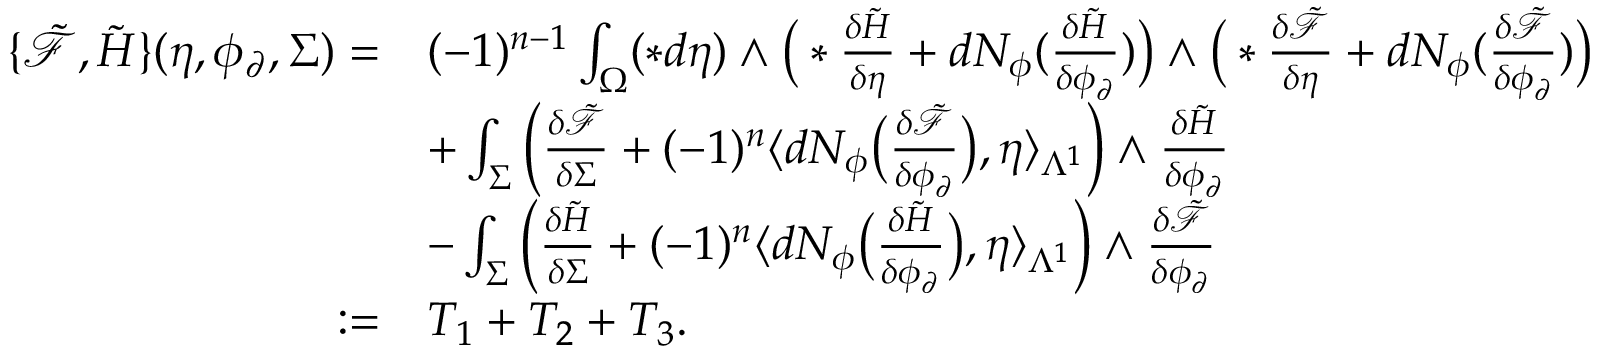Convert formula to latex. <formula><loc_0><loc_0><loc_500><loc_500>\begin{array} { r l } { \{ \tilde { \mathcal { F } } , \tilde { H } \} ( \eta , \phi _ { \partial } , \Sigma ) = } & { ( - 1 ) ^ { n - 1 } \int _ { \Omega } ( \ast d \eta ) \wedge \left ( \ast \frac { \delta \tilde { H } } { \delta \eta } + d N _ { \phi } ( \frac { \delta \tilde { H } } { \delta \phi _ { \partial } } ) \right ) \wedge \left ( \ast \frac { \delta \tilde { \mathcal { F } } } { \delta \eta } + d N _ { \phi } ( \frac { \delta \tilde { \mathcal { F } } } { \delta \phi _ { \partial } } ) \right ) } \\ & { + \int _ { \Sigma } \left ( \frac { \delta \tilde { \mathcal { F } } } { \delta \Sigma } + ( - 1 ) ^ { n } \langle d N _ { \phi } \left ( \frac { \delta \tilde { \mathcal { F } } } { \delta \phi _ { \partial } } \right ) , \eta \rangle _ { \Lambda ^ { 1 } } \right ) \wedge \frac { \delta \tilde { H } } { \delta \phi _ { \partial } } } \\ & { - \int _ { \Sigma } \left ( \frac { \delta \tilde { H } } { \delta \Sigma } + ( - 1 ) ^ { n } \langle d N _ { \phi } \left ( \frac { \delta \tilde { H } } { \delta \phi _ { \partial } } \right ) , \eta \rangle _ { \Lambda ^ { 1 } } \right ) \wedge \frac { \delta \tilde { \mathcal { F } } } { \delta \phi _ { \partial } } } \\ { \colon = } & { T _ { 1 } + T _ { 2 } + T _ { 3 } . } \end{array}</formula> 